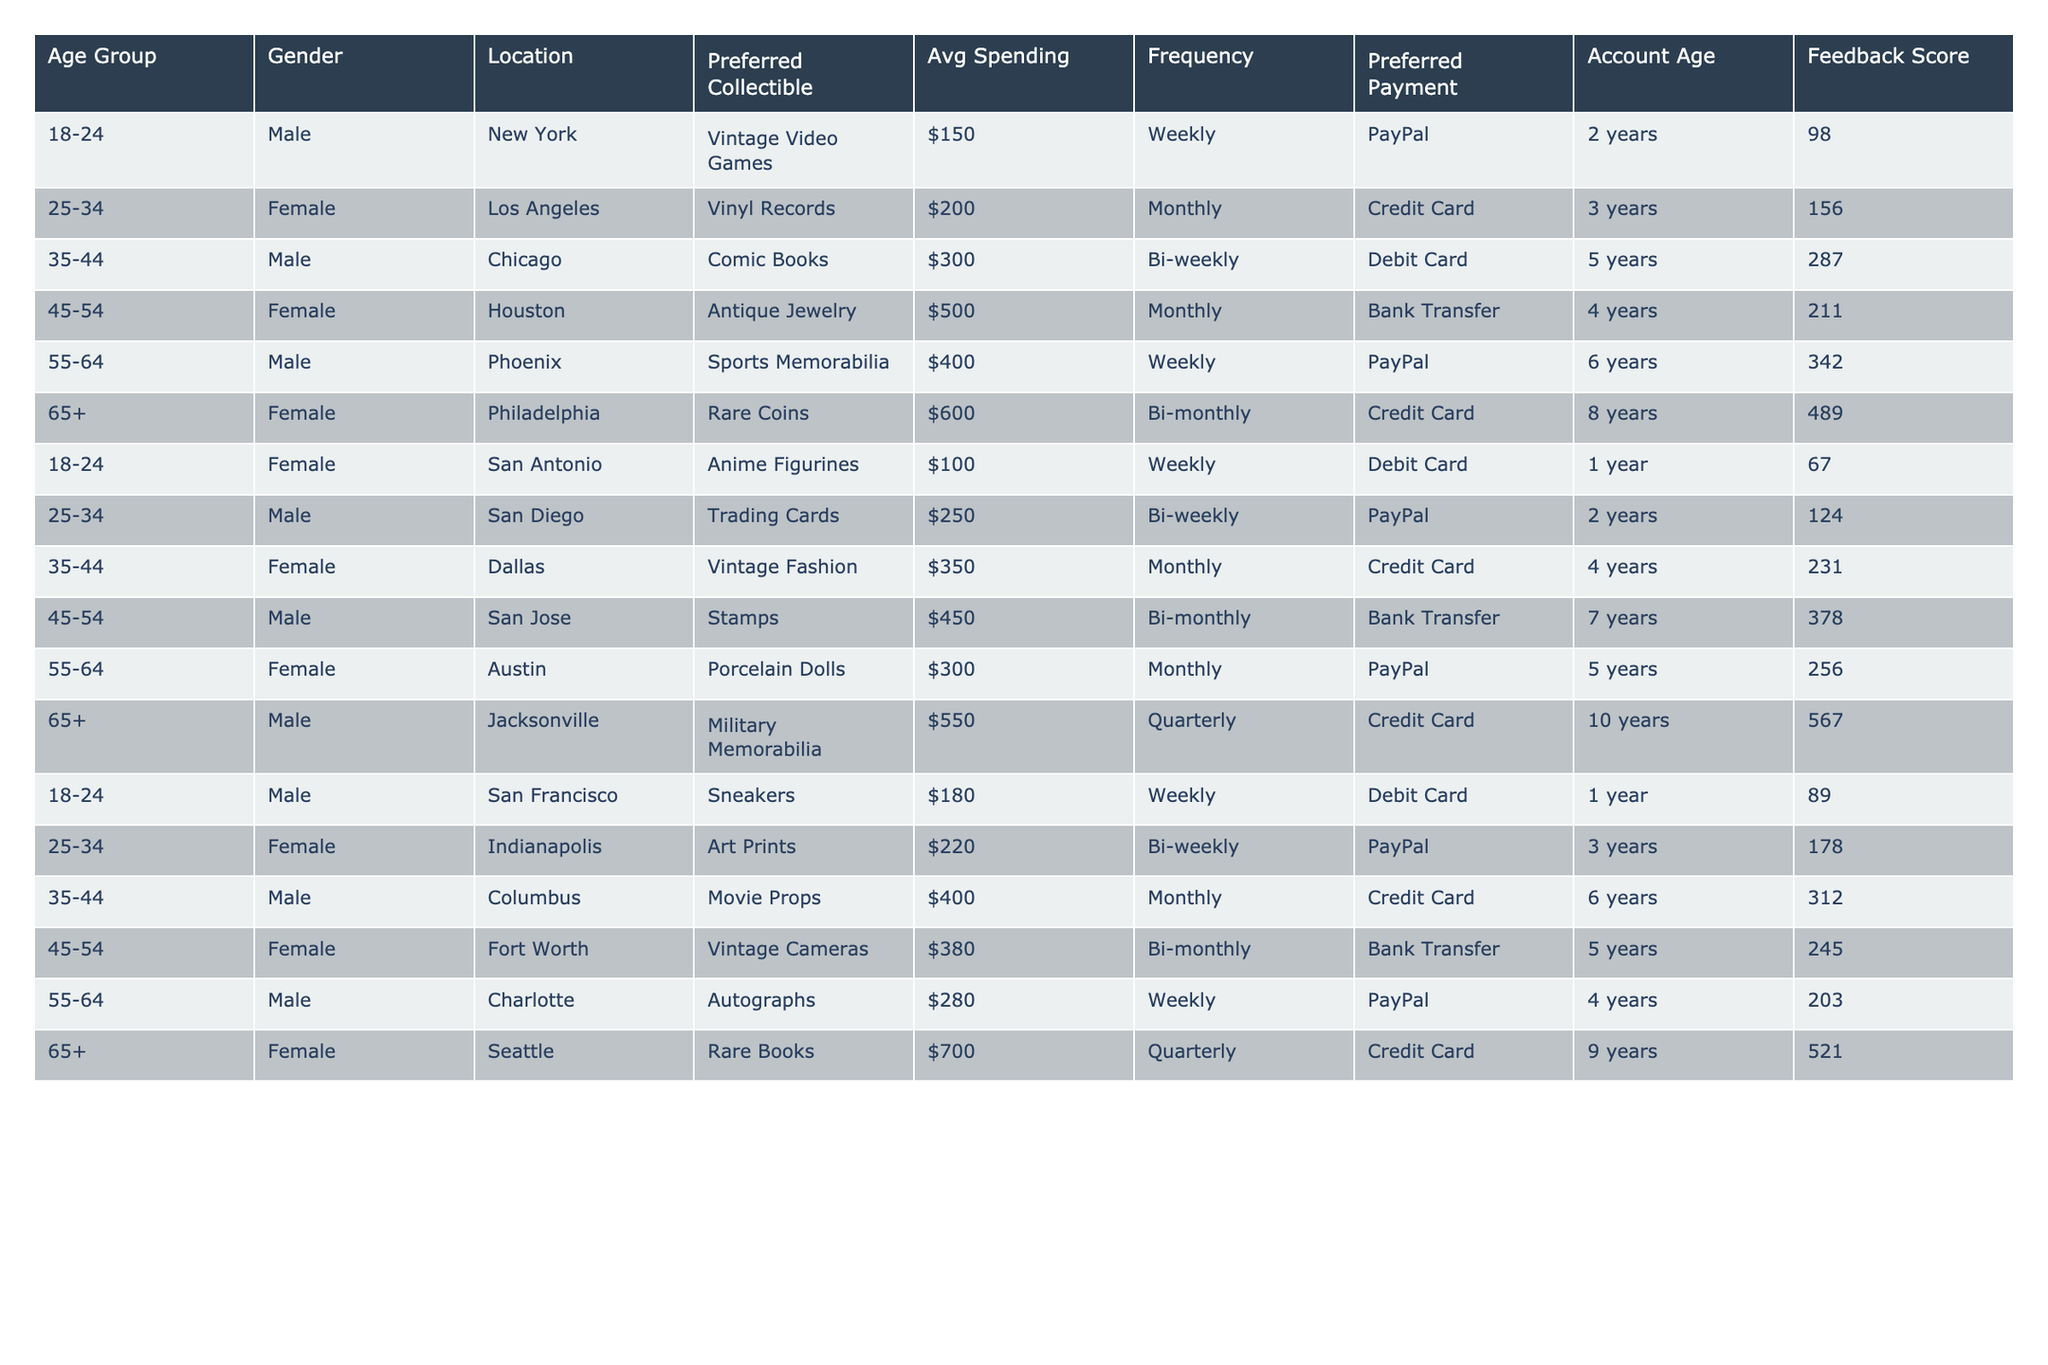What is the preferred collectible item for the age group 65+? In the table, under the age group 65+, the preferred collectible item is listed as "Rare Coins" for one female user from Philadelphia.
Answer: Rare Coins Which gender spends an average of $700, and what is their preferred collectible? A female from Seattle in the age group 65+ has an average spending of $700, with her preferred collectible being "Rare Books."
Answer: Female, Rare Books What is the average spending of males across all age groups? Summing the average spending of the males: $150 (18-24) + $300 (35-44) + $400 (55-64) + $250 (25-34) + $450 (45-54) + $180 (18-24) + $550 (65+) = $2280. There are 7 male participants, so the average spending is $2280/7 = $325.71.
Answer: $325.71 Is there a female account holder below the age of 25 who prefers anime figurines? A female from San Antonio in the age group 18-24 has been identified as preferring anime figurines.
Answer: Yes What is the total average spending of all users in the 35-44 age group? The average spending of users in the 35-44 age group includes $300 (Male, Comic Books) + $350 (Female, Vintage Fashion) + $400 (Male, Movie Props) = $1050. So, the total average spending is $1050.
Answer: $1050 What is the feedback score of the male user who prefers sports memorabilia? The male user from Phoenix, who prefers sports memorabilia, has a feedback score of 342.
Answer: 342 How many users have a spending average of over $500? User feedback shows that there are 3 individuals with an average spending over $500, specifically the female with rare books and the males with military memorabilia and antique jewelry.
Answer: 3 Which payment method is the most common among users aged 45-54? The payment methods used by age group 45-54 include Bank Transfer and PayPal, with Bank Transfer occurring 3 times compared to 2 for PayPal, making Bank Transfer the most common.
Answer: Bank Transfer What is the longest account age among all users, and who has it? The longest account age among users is 10 years, held by the male user from Jacksonville who prefers military memorabilia.
Answer: 10 years, Male from Jacksonville Are there any users who prefer vintage fashion that have provided below 200 feedback scores? The female user who prefers vintage fashion has a feedback score of 231, which is above 200. Therefore, there are no users who prefer vintage fashion with below 200 feedback scores.
Answer: No 